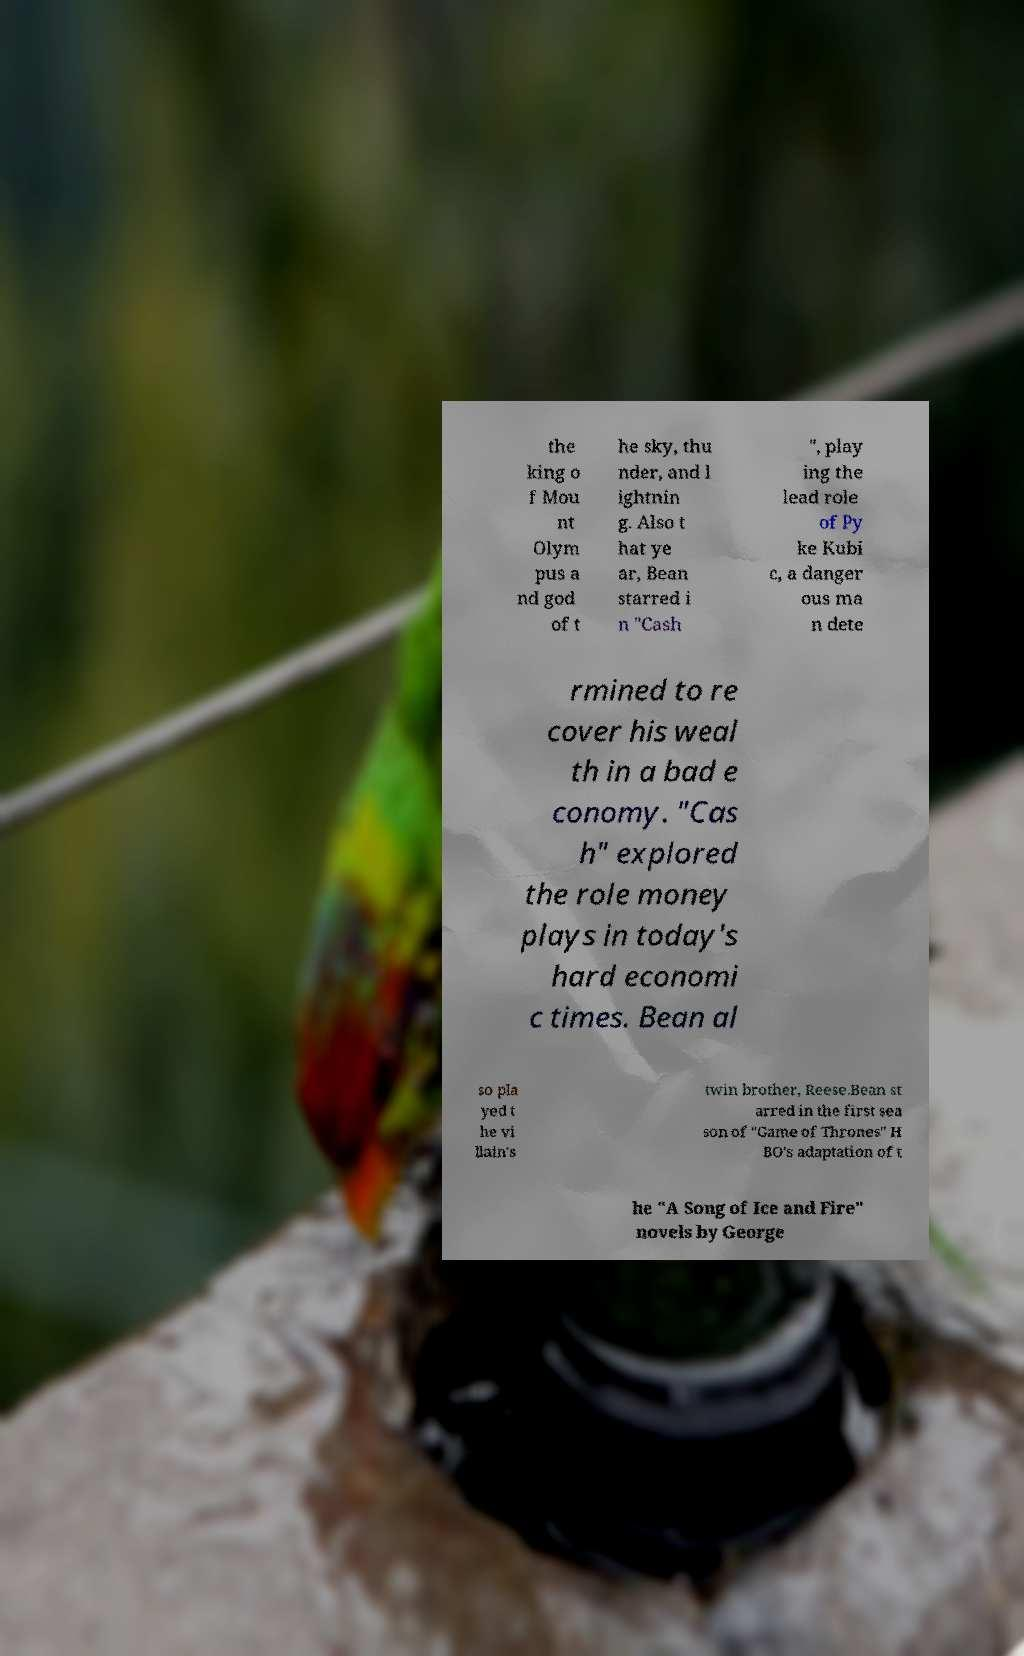There's text embedded in this image that I need extracted. Can you transcribe it verbatim? the king o f Mou nt Olym pus a nd god of t he sky, thu nder, and l ightnin g. Also t hat ye ar, Bean starred i n "Cash ", play ing the lead role of Py ke Kubi c, a danger ous ma n dete rmined to re cover his weal th in a bad e conomy. "Cas h" explored the role money plays in today's hard economi c times. Bean al so pla yed t he vi llain's twin brother, Reese.Bean st arred in the first sea son of "Game of Thrones" H BO's adaptation of t he "A Song of Ice and Fire" novels by George 